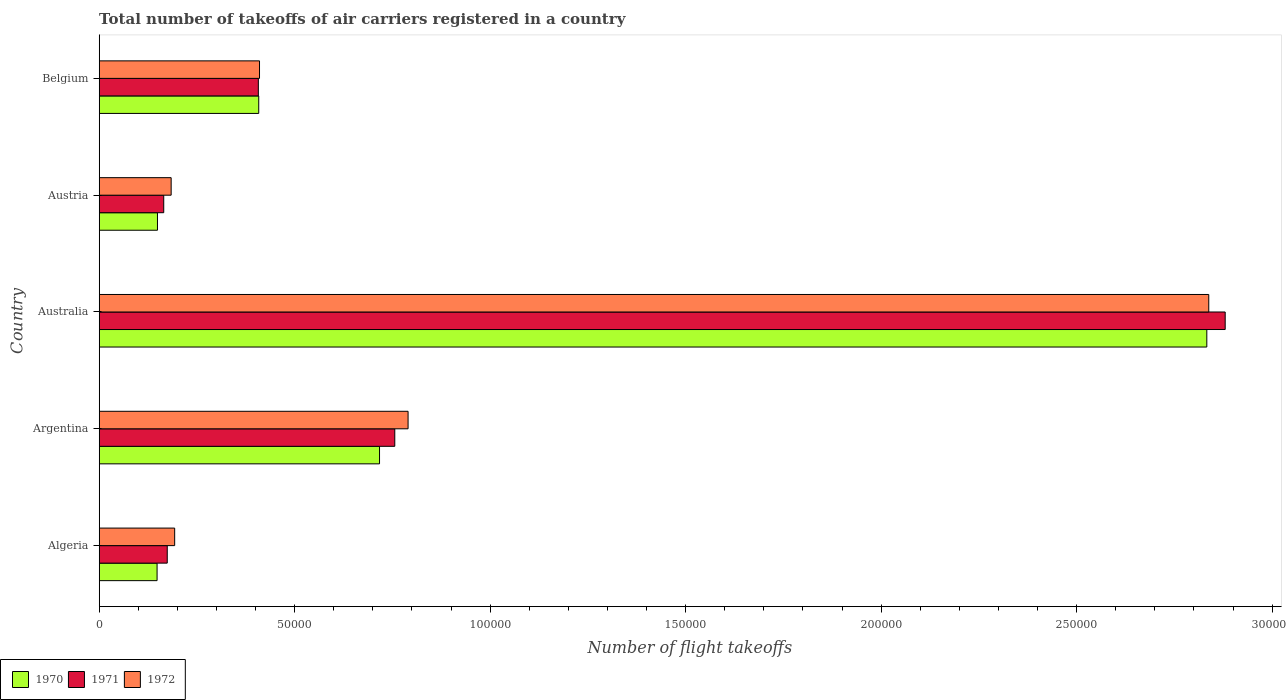Are the number of bars on each tick of the Y-axis equal?
Provide a short and direct response. Yes. How many bars are there on the 5th tick from the top?
Give a very brief answer. 3. What is the label of the 4th group of bars from the top?
Make the answer very short. Argentina. What is the total number of flight takeoffs in 1971 in Australia?
Provide a short and direct response. 2.88e+05. Across all countries, what is the maximum total number of flight takeoffs in 1971?
Your answer should be compact. 2.88e+05. Across all countries, what is the minimum total number of flight takeoffs in 1972?
Keep it short and to the point. 1.84e+04. In which country was the total number of flight takeoffs in 1970 minimum?
Ensure brevity in your answer.  Algeria. What is the total total number of flight takeoffs in 1970 in the graph?
Keep it short and to the point. 4.26e+05. What is the difference between the total number of flight takeoffs in 1972 in Austria and that in Belgium?
Ensure brevity in your answer.  -2.26e+04. What is the difference between the total number of flight takeoffs in 1972 in Australia and the total number of flight takeoffs in 1971 in Belgium?
Ensure brevity in your answer.  2.43e+05. What is the average total number of flight takeoffs in 1972 per country?
Ensure brevity in your answer.  8.83e+04. What is the difference between the total number of flight takeoffs in 1972 and total number of flight takeoffs in 1971 in Algeria?
Provide a short and direct response. 1900. In how many countries, is the total number of flight takeoffs in 1970 greater than 280000 ?
Offer a very short reply. 1. What is the ratio of the total number of flight takeoffs in 1972 in Algeria to that in Australia?
Your response must be concise. 0.07. Is the total number of flight takeoffs in 1971 in Algeria less than that in Austria?
Offer a terse response. No. What is the difference between the highest and the second highest total number of flight takeoffs in 1972?
Provide a succinct answer. 2.05e+05. What is the difference between the highest and the lowest total number of flight takeoffs in 1971?
Ensure brevity in your answer.  2.72e+05. In how many countries, is the total number of flight takeoffs in 1972 greater than the average total number of flight takeoffs in 1972 taken over all countries?
Your answer should be very brief. 1. Is the sum of the total number of flight takeoffs in 1970 in Australia and Austria greater than the maximum total number of flight takeoffs in 1972 across all countries?
Offer a very short reply. Yes. What does the 1st bar from the top in Austria represents?
Ensure brevity in your answer.  1972. What does the 3rd bar from the bottom in Austria represents?
Give a very brief answer. 1972. Is it the case that in every country, the sum of the total number of flight takeoffs in 1971 and total number of flight takeoffs in 1970 is greater than the total number of flight takeoffs in 1972?
Your answer should be very brief. Yes. How many countries are there in the graph?
Make the answer very short. 5. Does the graph contain any zero values?
Ensure brevity in your answer.  No. Does the graph contain grids?
Your answer should be very brief. No. What is the title of the graph?
Give a very brief answer. Total number of takeoffs of air carriers registered in a country. Does "1993" appear as one of the legend labels in the graph?
Offer a terse response. No. What is the label or title of the X-axis?
Your answer should be compact. Number of flight takeoffs. What is the Number of flight takeoffs in 1970 in Algeria?
Provide a short and direct response. 1.48e+04. What is the Number of flight takeoffs of 1971 in Algeria?
Your answer should be compact. 1.74e+04. What is the Number of flight takeoffs in 1972 in Algeria?
Make the answer very short. 1.93e+04. What is the Number of flight takeoffs in 1970 in Argentina?
Your response must be concise. 7.17e+04. What is the Number of flight takeoffs in 1971 in Argentina?
Offer a very short reply. 7.56e+04. What is the Number of flight takeoffs of 1972 in Argentina?
Give a very brief answer. 7.90e+04. What is the Number of flight takeoffs in 1970 in Australia?
Your answer should be very brief. 2.83e+05. What is the Number of flight takeoffs in 1971 in Australia?
Your answer should be very brief. 2.88e+05. What is the Number of flight takeoffs of 1972 in Australia?
Your response must be concise. 2.84e+05. What is the Number of flight takeoffs of 1970 in Austria?
Make the answer very short. 1.49e+04. What is the Number of flight takeoffs of 1971 in Austria?
Provide a short and direct response. 1.65e+04. What is the Number of flight takeoffs in 1972 in Austria?
Keep it short and to the point. 1.84e+04. What is the Number of flight takeoffs in 1970 in Belgium?
Give a very brief answer. 4.08e+04. What is the Number of flight takeoffs of 1971 in Belgium?
Your answer should be compact. 4.07e+04. What is the Number of flight takeoffs of 1972 in Belgium?
Make the answer very short. 4.10e+04. Across all countries, what is the maximum Number of flight takeoffs in 1970?
Your answer should be very brief. 2.83e+05. Across all countries, what is the maximum Number of flight takeoffs in 1971?
Your response must be concise. 2.88e+05. Across all countries, what is the maximum Number of flight takeoffs in 1972?
Ensure brevity in your answer.  2.84e+05. Across all countries, what is the minimum Number of flight takeoffs of 1970?
Keep it short and to the point. 1.48e+04. Across all countries, what is the minimum Number of flight takeoffs of 1971?
Provide a short and direct response. 1.65e+04. Across all countries, what is the minimum Number of flight takeoffs of 1972?
Make the answer very short. 1.84e+04. What is the total Number of flight takeoffs of 1970 in the graph?
Your answer should be very brief. 4.26e+05. What is the total Number of flight takeoffs in 1971 in the graph?
Provide a succinct answer. 4.38e+05. What is the total Number of flight takeoffs in 1972 in the graph?
Your response must be concise. 4.42e+05. What is the difference between the Number of flight takeoffs of 1970 in Algeria and that in Argentina?
Make the answer very short. -5.69e+04. What is the difference between the Number of flight takeoffs in 1971 in Algeria and that in Argentina?
Offer a very short reply. -5.82e+04. What is the difference between the Number of flight takeoffs of 1972 in Algeria and that in Argentina?
Your answer should be very brief. -5.97e+04. What is the difference between the Number of flight takeoffs of 1970 in Algeria and that in Australia?
Your answer should be very brief. -2.68e+05. What is the difference between the Number of flight takeoffs in 1971 in Algeria and that in Australia?
Make the answer very short. -2.71e+05. What is the difference between the Number of flight takeoffs of 1972 in Algeria and that in Australia?
Provide a short and direct response. -2.64e+05. What is the difference between the Number of flight takeoffs of 1970 in Algeria and that in Austria?
Your answer should be very brief. -100. What is the difference between the Number of flight takeoffs of 1971 in Algeria and that in Austria?
Keep it short and to the point. 900. What is the difference between the Number of flight takeoffs in 1972 in Algeria and that in Austria?
Your response must be concise. 900. What is the difference between the Number of flight takeoffs in 1970 in Algeria and that in Belgium?
Your answer should be very brief. -2.60e+04. What is the difference between the Number of flight takeoffs of 1971 in Algeria and that in Belgium?
Your answer should be very brief. -2.33e+04. What is the difference between the Number of flight takeoffs of 1972 in Algeria and that in Belgium?
Give a very brief answer. -2.17e+04. What is the difference between the Number of flight takeoffs of 1970 in Argentina and that in Australia?
Your response must be concise. -2.12e+05. What is the difference between the Number of flight takeoffs of 1971 in Argentina and that in Australia?
Provide a short and direct response. -2.12e+05. What is the difference between the Number of flight takeoffs in 1972 in Argentina and that in Australia?
Your response must be concise. -2.05e+05. What is the difference between the Number of flight takeoffs of 1970 in Argentina and that in Austria?
Give a very brief answer. 5.68e+04. What is the difference between the Number of flight takeoffs of 1971 in Argentina and that in Austria?
Offer a terse response. 5.91e+04. What is the difference between the Number of flight takeoffs in 1972 in Argentina and that in Austria?
Offer a terse response. 6.06e+04. What is the difference between the Number of flight takeoffs of 1970 in Argentina and that in Belgium?
Ensure brevity in your answer.  3.09e+04. What is the difference between the Number of flight takeoffs of 1971 in Argentina and that in Belgium?
Offer a very short reply. 3.49e+04. What is the difference between the Number of flight takeoffs of 1972 in Argentina and that in Belgium?
Provide a succinct answer. 3.80e+04. What is the difference between the Number of flight takeoffs in 1970 in Australia and that in Austria?
Make the answer very short. 2.68e+05. What is the difference between the Number of flight takeoffs in 1971 in Australia and that in Austria?
Offer a terse response. 2.72e+05. What is the difference between the Number of flight takeoffs of 1972 in Australia and that in Austria?
Offer a very short reply. 2.65e+05. What is the difference between the Number of flight takeoffs in 1970 in Australia and that in Belgium?
Your response must be concise. 2.42e+05. What is the difference between the Number of flight takeoffs of 1971 in Australia and that in Belgium?
Your answer should be compact. 2.47e+05. What is the difference between the Number of flight takeoffs in 1972 in Australia and that in Belgium?
Make the answer very short. 2.43e+05. What is the difference between the Number of flight takeoffs in 1970 in Austria and that in Belgium?
Ensure brevity in your answer.  -2.59e+04. What is the difference between the Number of flight takeoffs of 1971 in Austria and that in Belgium?
Provide a short and direct response. -2.42e+04. What is the difference between the Number of flight takeoffs in 1972 in Austria and that in Belgium?
Keep it short and to the point. -2.26e+04. What is the difference between the Number of flight takeoffs in 1970 in Algeria and the Number of flight takeoffs in 1971 in Argentina?
Provide a succinct answer. -6.08e+04. What is the difference between the Number of flight takeoffs in 1970 in Algeria and the Number of flight takeoffs in 1972 in Argentina?
Your answer should be compact. -6.42e+04. What is the difference between the Number of flight takeoffs in 1971 in Algeria and the Number of flight takeoffs in 1972 in Argentina?
Your response must be concise. -6.16e+04. What is the difference between the Number of flight takeoffs in 1970 in Algeria and the Number of flight takeoffs in 1971 in Australia?
Give a very brief answer. -2.73e+05. What is the difference between the Number of flight takeoffs in 1970 in Algeria and the Number of flight takeoffs in 1972 in Australia?
Offer a terse response. -2.69e+05. What is the difference between the Number of flight takeoffs of 1971 in Algeria and the Number of flight takeoffs of 1972 in Australia?
Offer a terse response. -2.66e+05. What is the difference between the Number of flight takeoffs of 1970 in Algeria and the Number of flight takeoffs of 1971 in Austria?
Your answer should be very brief. -1700. What is the difference between the Number of flight takeoffs of 1970 in Algeria and the Number of flight takeoffs of 1972 in Austria?
Ensure brevity in your answer.  -3600. What is the difference between the Number of flight takeoffs of 1971 in Algeria and the Number of flight takeoffs of 1972 in Austria?
Your response must be concise. -1000. What is the difference between the Number of flight takeoffs in 1970 in Algeria and the Number of flight takeoffs in 1971 in Belgium?
Provide a short and direct response. -2.59e+04. What is the difference between the Number of flight takeoffs in 1970 in Algeria and the Number of flight takeoffs in 1972 in Belgium?
Provide a short and direct response. -2.62e+04. What is the difference between the Number of flight takeoffs in 1971 in Algeria and the Number of flight takeoffs in 1972 in Belgium?
Offer a terse response. -2.36e+04. What is the difference between the Number of flight takeoffs in 1970 in Argentina and the Number of flight takeoffs in 1971 in Australia?
Your response must be concise. -2.16e+05. What is the difference between the Number of flight takeoffs in 1970 in Argentina and the Number of flight takeoffs in 1972 in Australia?
Offer a very short reply. -2.12e+05. What is the difference between the Number of flight takeoffs in 1971 in Argentina and the Number of flight takeoffs in 1972 in Australia?
Make the answer very short. -2.08e+05. What is the difference between the Number of flight takeoffs in 1970 in Argentina and the Number of flight takeoffs in 1971 in Austria?
Your response must be concise. 5.52e+04. What is the difference between the Number of flight takeoffs of 1970 in Argentina and the Number of flight takeoffs of 1972 in Austria?
Provide a succinct answer. 5.33e+04. What is the difference between the Number of flight takeoffs of 1971 in Argentina and the Number of flight takeoffs of 1972 in Austria?
Keep it short and to the point. 5.72e+04. What is the difference between the Number of flight takeoffs of 1970 in Argentina and the Number of flight takeoffs of 1971 in Belgium?
Keep it short and to the point. 3.10e+04. What is the difference between the Number of flight takeoffs of 1970 in Argentina and the Number of flight takeoffs of 1972 in Belgium?
Provide a short and direct response. 3.07e+04. What is the difference between the Number of flight takeoffs of 1971 in Argentina and the Number of flight takeoffs of 1972 in Belgium?
Keep it short and to the point. 3.46e+04. What is the difference between the Number of flight takeoffs in 1970 in Australia and the Number of flight takeoffs in 1971 in Austria?
Provide a short and direct response. 2.67e+05. What is the difference between the Number of flight takeoffs in 1970 in Australia and the Number of flight takeoffs in 1972 in Austria?
Ensure brevity in your answer.  2.65e+05. What is the difference between the Number of flight takeoffs of 1971 in Australia and the Number of flight takeoffs of 1972 in Austria?
Offer a terse response. 2.70e+05. What is the difference between the Number of flight takeoffs in 1970 in Australia and the Number of flight takeoffs in 1971 in Belgium?
Make the answer very short. 2.43e+05. What is the difference between the Number of flight takeoffs of 1970 in Australia and the Number of flight takeoffs of 1972 in Belgium?
Provide a short and direct response. 2.42e+05. What is the difference between the Number of flight takeoffs of 1971 in Australia and the Number of flight takeoffs of 1972 in Belgium?
Offer a terse response. 2.47e+05. What is the difference between the Number of flight takeoffs in 1970 in Austria and the Number of flight takeoffs in 1971 in Belgium?
Give a very brief answer. -2.58e+04. What is the difference between the Number of flight takeoffs in 1970 in Austria and the Number of flight takeoffs in 1972 in Belgium?
Provide a succinct answer. -2.61e+04. What is the difference between the Number of flight takeoffs of 1971 in Austria and the Number of flight takeoffs of 1972 in Belgium?
Your answer should be very brief. -2.45e+04. What is the average Number of flight takeoffs of 1970 per country?
Offer a terse response. 8.51e+04. What is the average Number of flight takeoffs in 1971 per country?
Provide a short and direct response. 8.76e+04. What is the average Number of flight takeoffs of 1972 per country?
Keep it short and to the point. 8.83e+04. What is the difference between the Number of flight takeoffs in 1970 and Number of flight takeoffs in 1971 in Algeria?
Your answer should be compact. -2600. What is the difference between the Number of flight takeoffs in 1970 and Number of flight takeoffs in 1972 in Algeria?
Your answer should be very brief. -4500. What is the difference between the Number of flight takeoffs in 1971 and Number of flight takeoffs in 1972 in Algeria?
Ensure brevity in your answer.  -1900. What is the difference between the Number of flight takeoffs in 1970 and Number of flight takeoffs in 1971 in Argentina?
Your answer should be very brief. -3900. What is the difference between the Number of flight takeoffs of 1970 and Number of flight takeoffs of 1972 in Argentina?
Your response must be concise. -7300. What is the difference between the Number of flight takeoffs of 1971 and Number of flight takeoffs of 1972 in Argentina?
Offer a terse response. -3400. What is the difference between the Number of flight takeoffs of 1970 and Number of flight takeoffs of 1971 in Australia?
Offer a terse response. -4700. What is the difference between the Number of flight takeoffs of 1970 and Number of flight takeoffs of 1972 in Australia?
Your answer should be very brief. -500. What is the difference between the Number of flight takeoffs of 1971 and Number of flight takeoffs of 1972 in Australia?
Provide a succinct answer. 4200. What is the difference between the Number of flight takeoffs in 1970 and Number of flight takeoffs in 1971 in Austria?
Your answer should be very brief. -1600. What is the difference between the Number of flight takeoffs of 1970 and Number of flight takeoffs of 1972 in Austria?
Ensure brevity in your answer.  -3500. What is the difference between the Number of flight takeoffs in 1971 and Number of flight takeoffs in 1972 in Austria?
Your answer should be compact. -1900. What is the difference between the Number of flight takeoffs in 1970 and Number of flight takeoffs in 1971 in Belgium?
Make the answer very short. 100. What is the difference between the Number of flight takeoffs of 1970 and Number of flight takeoffs of 1972 in Belgium?
Your response must be concise. -200. What is the difference between the Number of flight takeoffs in 1971 and Number of flight takeoffs in 1972 in Belgium?
Your answer should be very brief. -300. What is the ratio of the Number of flight takeoffs of 1970 in Algeria to that in Argentina?
Offer a very short reply. 0.21. What is the ratio of the Number of flight takeoffs in 1971 in Algeria to that in Argentina?
Your answer should be compact. 0.23. What is the ratio of the Number of flight takeoffs of 1972 in Algeria to that in Argentina?
Give a very brief answer. 0.24. What is the ratio of the Number of flight takeoffs of 1970 in Algeria to that in Australia?
Provide a succinct answer. 0.05. What is the ratio of the Number of flight takeoffs of 1971 in Algeria to that in Australia?
Offer a terse response. 0.06. What is the ratio of the Number of flight takeoffs of 1972 in Algeria to that in Australia?
Your answer should be very brief. 0.07. What is the ratio of the Number of flight takeoffs in 1970 in Algeria to that in Austria?
Offer a terse response. 0.99. What is the ratio of the Number of flight takeoffs in 1971 in Algeria to that in Austria?
Keep it short and to the point. 1.05. What is the ratio of the Number of flight takeoffs of 1972 in Algeria to that in Austria?
Give a very brief answer. 1.05. What is the ratio of the Number of flight takeoffs in 1970 in Algeria to that in Belgium?
Provide a short and direct response. 0.36. What is the ratio of the Number of flight takeoffs in 1971 in Algeria to that in Belgium?
Keep it short and to the point. 0.43. What is the ratio of the Number of flight takeoffs of 1972 in Algeria to that in Belgium?
Your answer should be very brief. 0.47. What is the ratio of the Number of flight takeoffs of 1970 in Argentina to that in Australia?
Your response must be concise. 0.25. What is the ratio of the Number of flight takeoffs of 1971 in Argentina to that in Australia?
Your response must be concise. 0.26. What is the ratio of the Number of flight takeoffs in 1972 in Argentina to that in Australia?
Offer a terse response. 0.28. What is the ratio of the Number of flight takeoffs of 1970 in Argentina to that in Austria?
Your response must be concise. 4.81. What is the ratio of the Number of flight takeoffs in 1971 in Argentina to that in Austria?
Make the answer very short. 4.58. What is the ratio of the Number of flight takeoffs in 1972 in Argentina to that in Austria?
Your answer should be very brief. 4.29. What is the ratio of the Number of flight takeoffs in 1970 in Argentina to that in Belgium?
Provide a succinct answer. 1.76. What is the ratio of the Number of flight takeoffs of 1971 in Argentina to that in Belgium?
Make the answer very short. 1.86. What is the ratio of the Number of flight takeoffs of 1972 in Argentina to that in Belgium?
Give a very brief answer. 1.93. What is the ratio of the Number of flight takeoffs of 1970 in Australia to that in Austria?
Your answer should be compact. 19.01. What is the ratio of the Number of flight takeoffs in 1971 in Australia to that in Austria?
Give a very brief answer. 17.45. What is the ratio of the Number of flight takeoffs of 1972 in Australia to that in Austria?
Ensure brevity in your answer.  15.42. What is the ratio of the Number of flight takeoffs of 1970 in Australia to that in Belgium?
Your response must be concise. 6.94. What is the ratio of the Number of flight takeoffs of 1971 in Australia to that in Belgium?
Make the answer very short. 7.08. What is the ratio of the Number of flight takeoffs of 1972 in Australia to that in Belgium?
Ensure brevity in your answer.  6.92. What is the ratio of the Number of flight takeoffs in 1970 in Austria to that in Belgium?
Provide a short and direct response. 0.37. What is the ratio of the Number of flight takeoffs in 1971 in Austria to that in Belgium?
Your answer should be very brief. 0.41. What is the ratio of the Number of flight takeoffs of 1972 in Austria to that in Belgium?
Give a very brief answer. 0.45. What is the difference between the highest and the second highest Number of flight takeoffs in 1970?
Offer a very short reply. 2.12e+05. What is the difference between the highest and the second highest Number of flight takeoffs of 1971?
Offer a terse response. 2.12e+05. What is the difference between the highest and the second highest Number of flight takeoffs in 1972?
Your response must be concise. 2.05e+05. What is the difference between the highest and the lowest Number of flight takeoffs in 1970?
Your answer should be compact. 2.68e+05. What is the difference between the highest and the lowest Number of flight takeoffs of 1971?
Ensure brevity in your answer.  2.72e+05. What is the difference between the highest and the lowest Number of flight takeoffs of 1972?
Your answer should be compact. 2.65e+05. 